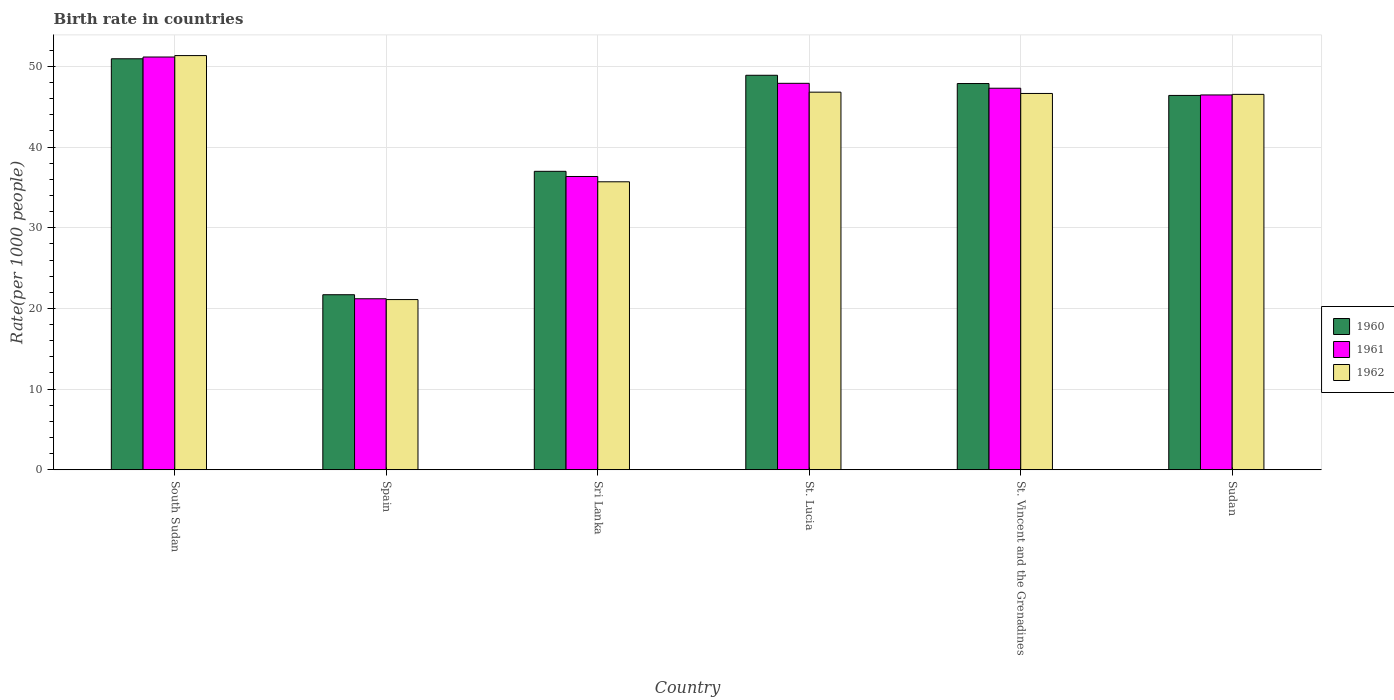Are the number of bars on each tick of the X-axis equal?
Offer a terse response. Yes. What is the label of the 5th group of bars from the left?
Offer a terse response. St. Vincent and the Grenadines. In how many cases, is the number of bars for a given country not equal to the number of legend labels?
Give a very brief answer. 0. What is the birth rate in 1960 in Sudan?
Offer a terse response. 46.4. Across all countries, what is the maximum birth rate in 1961?
Your response must be concise. 51.16. Across all countries, what is the minimum birth rate in 1962?
Give a very brief answer. 21.1. In which country was the birth rate in 1960 maximum?
Your response must be concise. South Sudan. What is the total birth rate in 1960 in the graph?
Give a very brief answer. 252.82. What is the difference between the birth rate in 1961 in South Sudan and that in St. Vincent and the Grenadines?
Offer a very short reply. 3.87. What is the difference between the birth rate in 1962 in Spain and the birth rate in 1961 in Sudan?
Offer a terse response. -25.36. What is the average birth rate in 1960 per country?
Your response must be concise. 42.14. What is the difference between the birth rate of/in 1962 and birth rate of/in 1960 in Spain?
Your answer should be very brief. -0.6. In how many countries, is the birth rate in 1961 greater than 10?
Offer a terse response. 6. What is the ratio of the birth rate in 1962 in South Sudan to that in St. Lucia?
Ensure brevity in your answer.  1.1. What is the difference between the highest and the second highest birth rate in 1962?
Offer a very short reply. -4.69. What is the difference between the highest and the lowest birth rate in 1960?
Offer a very short reply. 29.25. In how many countries, is the birth rate in 1962 greater than the average birth rate in 1962 taken over all countries?
Your answer should be compact. 4. What does the 1st bar from the left in St. Lucia represents?
Your answer should be compact. 1960. What does the 3rd bar from the right in South Sudan represents?
Your response must be concise. 1960. Are all the bars in the graph horizontal?
Provide a short and direct response. No. What is the difference between two consecutive major ticks on the Y-axis?
Provide a succinct answer. 10. Does the graph contain any zero values?
Your answer should be very brief. No. Where does the legend appear in the graph?
Your answer should be very brief. Center right. How many legend labels are there?
Keep it short and to the point. 3. How are the legend labels stacked?
Provide a succinct answer. Vertical. What is the title of the graph?
Give a very brief answer. Birth rate in countries. Does "2005" appear as one of the legend labels in the graph?
Provide a succinct answer. No. What is the label or title of the Y-axis?
Provide a short and direct response. Rate(per 1000 people). What is the Rate(per 1000 people) of 1960 in South Sudan?
Your answer should be compact. 50.95. What is the Rate(per 1000 people) in 1961 in South Sudan?
Your response must be concise. 51.16. What is the Rate(per 1000 people) of 1962 in South Sudan?
Your answer should be compact. 51.34. What is the Rate(per 1000 people) of 1960 in Spain?
Your answer should be compact. 21.7. What is the Rate(per 1000 people) of 1961 in Spain?
Offer a terse response. 21.2. What is the Rate(per 1000 people) in 1962 in Spain?
Provide a short and direct response. 21.1. What is the Rate(per 1000 people) in 1960 in Sri Lanka?
Provide a short and direct response. 37. What is the Rate(per 1000 people) in 1961 in Sri Lanka?
Ensure brevity in your answer.  36.36. What is the Rate(per 1000 people) of 1962 in Sri Lanka?
Your response must be concise. 35.7. What is the Rate(per 1000 people) of 1960 in St. Lucia?
Provide a short and direct response. 48.9. What is the Rate(per 1000 people) of 1961 in St. Lucia?
Keep it short and to the point. 47.9. What is the Rate(per 1000 people) in 1962 in St. Lucia?
Provide a succinct answer. 46.81. What is the Rate(per 1000 people) of 1960 in St. Vincent and the Grenadines?
Provide a short and direct response. 47.88. What is the Rate(per 1000 people) of 1961 in St. Vincent and the Grenadines?
Make the answer very short. 47.3. What is the Rate(per 1000 people) in 1962 in St. Vincent and the Grenadines?
Provide a succinct answer. 46.65. What is the Rate(per 1000 people) in 1960 in Sudan?
Your answer should be very brief. 46.4. What is the Rate(per 1000 people) in 1961 in Sudan?
Keep it short and to the point. 46.46. What is the Rate(per 1000 people) in 1962 in Sudan?
Make the answer very short. 46.53. Across all countries, what is the maximum Rate(per 1000 people) of 1960?
Provide a short and direct response. 50.95. Across all countries, what is the maximum Rate(per 1000 people) of 1961?
Your response must be concise. 51.16. Across all countries, what is the maximum Rate(per 1000 people) of 1962?
Ensure brevity in your answer.  51.34. Across all countries, what is the minimum Rate(per 1000 people) of 1960?
Provide a succinct answer. 21.7. Across all countries, what is the minimum Rate(per 1000 people) of 1961?
Offer a very short reply. 21.2. Across all countries, what is the minimum Rate(per 1000 people) in 1962?
Give a very brief answer. 21.1. What is the total Rate(per 1000 people) in 1960 in the graph?
Make the answer very short. 252.82. What is the total Rate(per 1000 people) in 1961 in the graph?
Provide a succinct answer. 250.38. What is the total Rate(per 1000 people) in 1962 in the graph?
Offer a very short reply. 248.13. What is the difference between the Rate(per 1000 people) of 1960 in South Sudan and that in Spain?
Offer a terse response. 29.25. What is the difference between the Rate(per 1000 people) in 1961 in South Sudan and that in Spain?
Make the answer very short. 29.96. What is the difference between the Rate(per 1000 people) in 1962 in South Sudan and that in Spain?
Offer a very short reply. 30.24. What is the difference between the Rate(per 1000 people) of 1960 in South Sudan and that in Sri Lanka?
Offer a very short reply. 13.95. What is the difference between the Rate(per 1000 people) of 1961 in South Sudan and that in Sri Lanka?
Keep it short and to the point. 14.81. What is the difference between the Rate(per 1000 people) of 1962 in South Sudan and that in Sri Lanka?
Make the answer very short. 15.64. What is the difference between the Rate(per 1000 people) in 1960 in South Sudan and that in St. Lucia?
Your answer should be very brief. 2.04. What is the difference between the Rate(per 1000 people) of 1961 in South Sudan and that in St. Lucia?
Ensure brevity in your answer.  3.26. What is the difference between the Rate(per 1000 people) in 1962 in South Sudan and that in St. Lucia?
Make the answer very short. 4.53. What is the difference between the Rate(per 1000 people) of 1960 in South Sudan and that in St. Vincent and the Grenadines?
Ensure brevity in your answer.  3.07. What is the difference between the Rate(per 1000 people) of 1961 in South Sudan and that in St. Vincent and the Grenadines?
Offer a terse response. 3.87. What is the difference between the Rate(per 1000 people) in 1962 in South Sudan and that in St. Vincent and the Grenadines?
Ensure brevity in your answer.  4.69. What is the difference between the Rate(per 1000 people) in 1960 in South Sudan and that in Sudan?
Make the answer very short. 4.54. What is the difference between the Rate(per 1000 people) in 1961 in South Sudan and that in Sudan?
Ensure brevity in your answer.  4.7. What is the difference between the Rate(per 1000 people) of 1962 in South Sudan and that in Sudan?
Make the answer very short. 4.81. What is the difference between the Rate(per 1000 people) in 1960 in Spain and that in Sri Lanka?
Your answer should be very brief. -15.3. What is the difference between the Rate(per 1000 people) in 1961 in Spain and that in Sri Lanka?
Provide a short and direct response. -15.16. What is the difference between the Rate(per 1000 people) in 1962 in Spain and that in Sri Lanka?
Offer a very short reply. -14.6. What is the difference between the Rate(per 1000 people) in 1960 in Spain and that in St. Lucia?
Your response must be concise. -27.2. What is the difference between the Rate(per 1000 people) of 1961 in Spain and that in St. Lucia?
Your response must be concise. -26.7. What is the difference between the Rate(per 1000 people) of 1962 in Spain and that in St. Lucia?
Your answer should be very brief. -25.71. What is the difference between the Rate(per 1000 people) of 1960 in Spain and that in St. Vincent and the Grenadines?
Ensure brevity in your answer.  -26.18. What is the difference between the Rate(per 1000 people) of 1961 in Spain and that in St. Vincent and the Grenadines?
Keep it short and to the point. -26.1. What is the difference between the Rate(per 1000 people) of 1962 in Spain and that in St. Vincent and the Grenadines?
Offer a very short reply. -25.55. What is the difference between the Rate(per 1000 people) in 1960 in Spain and that in Sudan?
Your answer should be very brief. -24.7. What is the difference between the Rate(per 1000 people) of 1961 in Spain and that in Sudan?
Your answer should be compact. -25.26. What is the difference between the Rate(per 1000 people) in 1962 in Spain and that in Sudan?
Offer a very short reply. -25.43. What is the difference between the Rate(per 1000 people) of 1960 in Sri Lanka and that in St. Lucia?
Provide a succinct answer. -11.9. What is the difference between the Rate(per 1000 people) of 1961 in Sri Lanka and that in St. Lucia?
Ensure brevity in your answer.  -11.55. What is the difference between the Rate(per 1000 people) of 1962 in Sri Lanka and that in St. Lucia?
Keep it short and to the point. -11.11. What is the difference between the Rate(per 1000 people) in 1960 in Sri Lanka and that in St. Vincent and the Grenadines?
Ensure brevity in your answer.  -10.88. What is the difference between the Rate(per 1000 people) in 1961 in Sri Lanka and that in St. Vincent and the Grenadines?
Give a very brief answer. -10.94. What is the difference between the Rate(per 1000 people) in 1962 in Sri Lanka and that in St. Vincent and the Grenadines?
Offer a terse response. -10.95. What is the difference between the Rate(per 1000 people) in 1960 in Sri Lanka and that in Sudan?
Provide a succinct answer. -9.41. What is the difference between the Rate(per 1000 people) of 1961 in Sri Lanka and that in Sudan?
Offer a terse response. -10.11. What is the difference between the Rate(per 1000 people) of 1962 in Sri Lanka and that in Sudan?
Provide a short and direct response. -10.84. What is the difference between the Rate(per 1000 people) of 1961 in St. Lucia and that in St. Vincent and the Grenadines?
Ensure brevity in your answer.  0.61. What is the difference between the Rate(per 1000 people) of 1962 in St. Lucia and that in St. Vincent and the Grenadines?
Ensure brevity in your answer.  0.16. What is the difference between the Rate(per 1000 people) of 1960 in St. Lucia and that in Sudan?
Your answer should be compact. 2.5. What is the difference between the Rate(per 1000 people) in 1961 in St. Lucia and that in Sudan?
Provide a short and direct response. 1.44. What is the difference between the Rate(per 1000 people) of 1962 in St. Lucia and that in Sudan?
Provide a succinct answer. 0.27. What is the difference between the Rate(per 1000 people) in 1960 in St. Vincent and the Grenadines and that in Sudan?
Provide a short and direct response. 1.47. What is the difference between the Rate(per 1000 people) of 1961 in St. Vincent and the Grenadines and that in Sudan?
Offer a very short reply. 0.83. What is the difference between the Rate(per 1000 people) in 1962 in St. Vincent and the Grenadines and that in Sudan?
Keep it short and to the point. 0.11. What is the difference between the Rate(per 1000 people) of 1960 in South Sudan and the Rate(per 1000 people) of 1961 in Spain?
Provide a short and direct response. 29.75. What is the difference between the Rate(per 1000 people) of 1960 in South Sudan and the Rate(per 1000 people) of 1962 in Spain?
Keep it short and to the point. 29.84. What is the difference between the Rate(per 1000 people) in 1961 in South Sudan and the Rate(per 1000 people) in 1962 in Spain?
Your answer should be very brief. 30.07. What is the difference between the Rate(per 1000 people) of 1960 in South Sudan and the Rate(per 1000 people) of 1961 in Sri Lanka?
Offer a terse response. 14.59. What is the difference between the Rate(per 1000 people) of 1960 in South Sudan and the Rate(per 1000 people) of 1962 in Sri Lanka?
Offer a terse response. 15.25. What is the difference between the Rate(per 1000 people) of 1961 in South Sudan and the Rate(per 1000 people) of 1962 in Sri Lanka?
Your response must be concise. 15.47. What is the difference between the Rate(per 1000 people) in 1960 in South Sudan and the Rate(per 1000 people) in 1961 in St. Lucia?
Make the answer very short. 3.04. What is the difference between the Rate(per 1000 people) of 1960 in South Sudan and the Rate(per 1000 people) of 1962 in St. Lucia?
Make the answer very short. 4.14. What is the difference between the Rate(per 1000 people) of 1961 in South Sudan and the Rate(per 1000 people) of 1962 in St. Lucia?
Offer a terse response. 4.36. What is the difference between the Rate(per 1000 people) of 1960 in South Sudan and the Rate(per 1000 people) of 1961 in St. Vincent and the Grenadines?
Your answer should be very brief. 3.65. What is the difference between the Rate(per 1000 people) of 1960 in South Sudan and the Rate(per 1000 people) of 1962 in St. Vincent and the Grenadines?
Ensure brevity in your answer.  4.3. What is the difference between the Rate(per 1000 people) of 1961 in South Sudan and the Rate(per 1000 people) of 1962 in St. Vincent and the Grenadines?
Provide a short and direct response. 4.52. What is the difference between the Rate(per 1000 people) of 1960 in South Sudan and the Rate(per 1000 people) of 1961 in Sudan?
Ensure brevity in your answer.  4.48. What is the difference between the Rate(per 1000 people) in 1960 in South Sudan and the Rate(per 1000 people) in 1962 in Sudan?
Ensure brevity in your answer.  4.41. What is the difference between the Rate(per 1000 people) in 1961 in South Sudan and the Rate(per 1000 people) in 1962 in Sudan?
Ensure brevity in your answer.  4.63. What is the difference between the Rate(per 1000 people) of 1960 in Spain and the Rate(per 1000 people) of 1961 in Sri Lanka?
Make the answer very short. -14.66. What is the difference between the Rate(per 1000 people) of 1960 in Spain and the Rate(per 1000 people) of 1962 in Sri Lanka?
Make the answer very short. -14. What is the difference between the Rate(per 1000 people) in 1961 in Spain and the Rate(per 1000 people) in 1962 in Sri Lanka?
Offer a very short reply. -14.5. What is the difference between the Rate(per 1000 people) of 1960 in Spain and the Rate(per 1000 people) of 1961 in St. Lucia?
Provide a short and direct response. -26.2. What is the difference between the Rate(per 1000 people) in 1960 in Spain and the Rate(per 1000 people) in 1962 in St. Lucia?
Offer a terse response. -25.11. What is the difference between the Rate(per 1000 people) of 1961 in Spain and the Rate(per 1000 people) of 1962 in St. Lucia?
Offer a terse response. -25.61. What is the difference between the Rate(per 1000 people) in 1960 in Spain and the Rate(per 1000 people) in 1961 in St. Vincent and the Grenadines?
Provide a succinct answer. -25.6. What is the difference between the Rate(per 1000 people) of 1960 in Spain and the Rate(per 1000 people) of 1962 in St. Vincent and the Grenadines?
Your answer should be compact. -24.95. What is the difference between the Rate(per 1000 people) of 1961 in Spain and the Rate(per 1000 people) of 1962 in St. Vincent and the Grenadines?
Give a very brief answer. -25.45. What is the difference between the Rate(per 1000 people) of 1960 in Spain and the Rate(per 1000 people) of 1961 in Sudan?
Keep it short and to the point. -24.76. What is the difference between the Rate(per 1000 people) of 1960 in Spain and the Rate(per 1000 people) of 1962 in Sudan?
Give a very brief answer. -24.83. What is the difference between the Rate(per 1000 people) of 1961 in Spain and the Rate(per 1000 people) of 1962 in Sudan?
Keep it short and to the point. -25.33. What is the difference between the Rate(per 1000 people) of 1960 in Sri Lanka and the Rate(per 1000 people) of 1961 in St. Lucia?
Provide a short and direct response. -10.91. What is the difference between the Rate(per 1000 people) in 1960 in Sri Lanka and the Rate(per 1000 people) in 1962 in St. Lucia?
Ensure brevity in your answer.  -9.81. What is the difference between the Rate(per 1000 people) of 1961 in Sri Lanka and the Rate(per 1000 people) of 1962 in St. Lucia?
Provide a short and direct response. -10.45. What is the difference between the Rate(per 1000 people) in 1960 in Sri Lanka and the Rate(per 1000 people) in 1961 in St. Vincent and the Grenadines?
Your answer should be very brief. -10.3. What is the difference between the Rate(per 1000 people) in 1960 in Sri Lanka and the Rate(per 1000 people) in 1962 in St. Vincent and the Grenadines?
Your answer should be compact. -9.65. What is the difference between the Rate(per 1000 people) of 1961 in Sri Lanka and the Rate(per 1000 people) of 1962 in St. Vincent and the Grenadines?
Give a very brief answer. -10.29. What is the difference between the Rate(per 1000 people) of 1960 in Sri Lanka and the Rate(per 1000 people) of 1961 in Sudan?
Provide a short and direct response. -9.46. What is the difference between the Rate(per 1000 people) of 1960 in Sri Lanka and the Rate(per 1000 people) of 1962 in Sudan?
Your answer should be very brief. -9.54. What is the difference between the Rate(per 1000 people) in 1961 in Sri Lanka and the Rate(per 1000 people) in 1962 in Sudan?
Your answer should be compact. -10.18. What is the difference between the Rate(per 1000 people) in 1960 in St. Lucia and the Rate(per 1000 people) in 1961 in St. Vincent and the Grenadines?
Offer a very short reply. 1.6. What is the difference between the Rate(per 1000 people) of 1960 in St. Lucia and the Rate(per 1000 people) of 1962 in St. Vincent and the Grenadines?
Provide a short and direct response. 2.25. What is the difference between the Rate(per 1000 people) in 1961 in St. Lucia and the Rate(per 1000 people) in 1962 in St. Vincent and the Grenadines?
Ensure brevity in your answer.  1.26. What is the difference between the Rate(per 1000 people) in 1960 in St. Lucia and the Rate(per 1000 people) in 1961 in Sudan?
Provide a succinct answer. 2.44. What is the difference between the Rate(per 1000 people) in 1960 in St. Lucia and the Rate(per 1000 people) in 1962 in Sudan?
Your answer should be very brief. 2.37. What is the difference between the Rate(per 1000 people) of 1961 in St. Lucia and the Rate(per 1000 people) of 1962 in Sudan?
Your answer should be compact. 1.37. What is the difference between the Rate(per 1000 people) in 1960 in St. Vincent and the Grenadines and the Rate(per 1000 people) in 1961 in Sudan?
Provide a succinct answer. 1.42. What is the difference between the Rate(per 1000 people) in 1960 in St. Vincent and the Grenadines and the Rate(per 1000 people) in 1962 in Sudan?
Offer a very short reply. 1.34. What is the difference between the Rate(per 1000 people) in 1961 in St. Vincent and the Grenadines and the Rate(per 1000 people) in 1962 in Sudan?
Offer a terse response. 0.76. What is the average Rate(per 1000 people) of 1960 per country?
Ensure brevity in your answer.  42.14. What is the average Rate(per 1000 people) in 1961 per country?
Provide a short and direct response. 41.73. What is the average Rate(per 1000 people) of 1962 per country?
Your answer should be very brief. 41.35. What is the difference between the Rate(per 1000 people) in 1960 and Rate(per 1000 people) in 1961 in South Sudan?
Ensure brevity in your answer.  -0.22. What is the difference between the Rate(per 1000 people) of 1960 and Rate(per 1000 people) of 1962 in South Sudan?
Offer a very short reply. -0.4. What is the difference between the Rate(per 1000 people) in 1961 and Rate(per 1000 people) in 1962 in South Sudan?
Give a very brief answer. -0.18. What is the difference between the Rate(per 1000 people) of 1960 and Rate(per 1000 people) of 1961 in Sri Lanka?
Make the answer very short. 0.64. What is the difference between the Rate(per 1000 people) of 1960 and Rate(per 1000 people) of 1962 in Sri Lanka?
Offer a very short reply. 1.3. What is the difference between the Rate(per 1000 people) in 1961 and Rate(per 1000 people) in 1962 in Sri Lanka?
Your response must be concise. 0.66. What is the difference between the Rate(per 1000 people) in 1960 and Rate(per 1000 people) in 1962 in St. Lucia?
Give a very brief answer. 2.09. What is the difference between the Rate(per 1000 people) of 1961 and Rate(per 1000 people) of 1962 in St. Lucia?
Your answer should be very brief. 1.1. What is the difference between the Rate(per 1000 people) of 1960 and Rate(per 1000 people) of 1961 in St. Vincent and the Grenadines?
Your answer should be very brief. 0.58. What is the difference between the Rate(per 1000 people) of 1960 and Rate(per 1000 people) of 1962 in St. Vincent and the Grenadines?
Offer a terse response. 1.23. What is the difference between the Rate(per 1000 people) of 1961 and Rate(per 1000 people) of 1962 in St. Vincent and the Grenadines?
Your answer should be compact. 0.65. What is the difference between the Rate(per 1000 people) in 1960 and Rate(per 1000 people) in 1961 in Sudan?
Ensure brevity in your answer.  -0.06. What is the difference between the Rate(per 1000 people) in 1960 and Rate(per 1000 people) in 1962 in Sudan?
Provide a short and direct response. -0.13. What is the difference between the Rate(per 1000 people) of 1961 and Rate(per 1000 people) of 1962 in Sudan?
Your response must be concise. -0.07. What is the ratio of the Rate(per 1000 people) of 1960 in South Sudan to that in Spain?
Ensure brevity in your answer.  2.35. What is the ratio of the Rate(per 1000 people) in 1961 in South Sudan to that in Spain?
Offer a terse response. 2.41. What is the ratio of the Rate(per 1000 people) of 1962 in South Sudan to that in Spain?
Ensure brevity in your answer.  2.43. What is the ratio of the Rate(per 1000 people) of 1960 in South Sudan to that in Sri Lanka?
Your answer should be compact. 1.38. What is the ratio of the Rate(per 1000 people) of 1961 in South Sudan to that in Sri Lanka?
Give a very brief answer. 1.41. What is the ratio of the Rate(per 1000 people) of 1962 in South Sudan to that in Sri Lanka?
Offer a terse response. 1.44. What is the ratio of the Rate(per 1000 people) in 1960 in South Sudan to that in St. Lucia?
Give a very brief answer. 1.04. What is the ratio of the Rate(per 1000 people) in 1961 in South Sudan to that in St. Lucia?
Ensure brevity in your answer.  1.07. What is the ratio of the Rate(per 1000 people) in 1962 in South Sudan to that in St. Lucia?
Provide a succinct answer. 1.1. What is the ratio of the Rate(per 1000 people) in 1960 in South Sudan to that in St. Vincent and the Grenadines?
Make the answer very short. 1.06. What is the ratio of the Rate(per 1000 people) of 1961 in South Sudan to that in St. Vincent and the Grenadines?
Keep it short and to the point. 1.08. What is the ratio of the Rate(per 1000 people) of 1962 in South Sudan to that in St. Vincent and the Grenadines?
Your answer should be very brief. 1.1. What is the ratio of the Rate(per 1000 people) in 1960 in South Sudan to that in Sudan?
Provide a succinct answer. 1.1. What is the ratio of the Rate(per 1000 people) in 1961 in South Sudan to that in Sudan?
Keep it short and to the point. 1.1. What is the ratio of the Rate(per 1000 people) in 1962 in South Sudan to that in Sudan?
Offer a terse response. 1.1. What is the ratio of the Rate(per 1000 people) of 1960 in Spain to that in Sri Lanka?
Provide a short and direct response. 0.59. What is the ratio of the Rate(per 1000 people) in 1961 in Spain to that in Sri Lanka?
Offer a terse response. 0.58. What is the ratio of the Rate(per 1000 people) in 1962 in Spain to that in Sri Lanka?
Make the answer very short. 0.59. What is the ratio of the Rate(per 1000 people) in 1960 in Spain to that in St. Lucia?
Ensure brevity in your answer.  0.44. What is the ratio of the Rate(per 1000 people) of 1961 in Spain to that in St. Lucia?
Offer a very short reply. 0.44. What is the ratio of the Rate(per 1000 people) in 1962 in Spain to that in St. Lucia?
Offer a terse response. 0.45. What is the ratio of the Rate(per 1000 people) of 1960 in Spain to that in St. Vincent and the Grenadines?
Offer a very short reply. 0.45. What is the ratio of the Rate(per 1000 people) in 1961 in Spain to that in St. Vincent and the Grenadines?
Provide a succinct answer. 0.45. What is the ratio of the Rate(per 1000 people) of 1962 in Spain to that in St. Vincent and the Grenadines?
Provide a succinct answer. 0.45. What is the ratio of the Rate(per 1000 people) in 1960 in Spain to that in Sudan?
Give a very brief answer. 0.47. What is the ratio of the Rate(per 1000 people) in 1961 in Spain to that in Sudan?
Ensure brevity in your answer.  0.46. What is the ratio of the Rate(per 1000 people) of 1962 in Spain to that in Sudan?
Offer a terse response. 0.45. What is the ratio of the Rate(per 1000 people) of 1960 in Sri Lanka to that in St. Lucia?
Provide a short and direct response. 0.76. What is the ratio of the Rate(per 1000 people) of 1961 in Sri Lanka to that in St. Lucia?
Provide a short and direct response. 0.76. What is the ratio of the Rate(per 1000 people) in 1962 in Sri Lanka to that in St. Lucia?
Offer a terse response. 0.76. What is the ratio of the Rate(per 1000 people) of 1960 in Sri Lanka to that in St. Vincent and the Grenadines?
Ensure brevity in your answer.  0.77. What is the ratio of the Rate(per 1000 people) of 1961 in Sri Lanka to that in St. Vincent and the Grenadines?
Provide a succinct answer. 0.77. What is the ratio of the Rate(per 1000 people) of 1962 in Sri Lanka to that in St. Vincent and the Grenadines?
Provide a succinct answer. 0.77. What is the ratio of the Rate(per 1000 people) in 1960 in Sri Lanka to that in Sudan?
Your answer should be very brief. 0.8. What is the ratio of the Rate(per 1000 people) of 1961 in Sri Lanka to that in Sudan?
Provide a short and direct response. 0.78. What is the ratio of the Rate(per 1000 people) in 1962 in Sri Lanka to that in Sudan?
Give a very brief answer. 0.77. What is the ratio of the Rate(per 1000 people) in 1960 in St. Lucia to that in St. Vincent and the Grenadines?
Keep it short and to the point. 1.02. What is the ratio of the Rate(per 1000 people) in 1961 in St. Lucia to that in St. Vincent and the Grenadines?
Your answer should be compact. 1.01. What is the ratio of the Rate(per 1000 people) of 1960 in St. Lucia to that in Sudan?
Offer a very short reply. 1.05. What is the ratio of the Rate(per 1000 people) in 1961 in St. Lucia to that in Sudan?
Keep it short and to the point. 1.03. What is the ratio of the Rate(per 1000 people) of 1962 in St. Lucia to that in Sudan?
Make the answer very short. 1.01. What is the ratio of the Rate(per 1000 people) of 1960 in St. Vincent and the Grenadines to that in Sudan?
Your answer should be compact. 1.03. What is the ratio of the Rate(per 1000 people) in 1962 in St. Vincent and the Grenadines to that in Sudan?
Make the answer very short. 1. What is the difference between the highest and the second highest Rate(per 1000 people) in 1960?
Your answer should be very brief. 2.04. What is the difference between the highest and the second highest Rate(per 1000 people) of 1961?
Provide a short and direct response. 3.26. What is the difference between the highest and the second highest Rate(per 1000 people) in 1962?
Give a very brief answer. 4.53. What is the difference between the highest and the lowest Rate(per 1000 people) in 1960?
Provide a short and direct response. 29.25. What is the difference between the highest and the lowest Rate(per 1000 people) of 1961?
Provide a short and direct response. 29.96. What is the difference between the highest and the lowest Rate(per 1000 people) of 1962?
Provide a short and direct response. 30.24. 